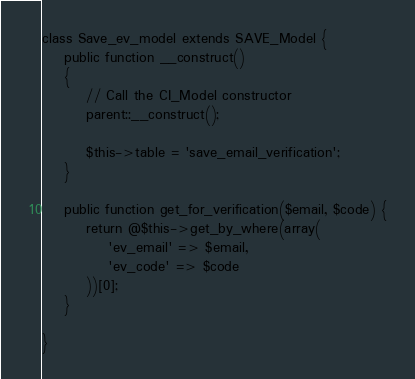Convert code to text. <code><loc_0><loc_0><loc_500><loc_500><_PHP_>class Save_ev_model extends SAVE_Model {
    public function __construct()
    {
        // Call the CI_Model constructor
        parent::__construct();

        $this->table = 'save_email_verification';
    }

    public function get_for_verification($email, $code) {
        return @$this->get_by_where(array(
            'ev_email' => $email,
            'ev_code' => $code
        ))[0];
    }

}
</code> 